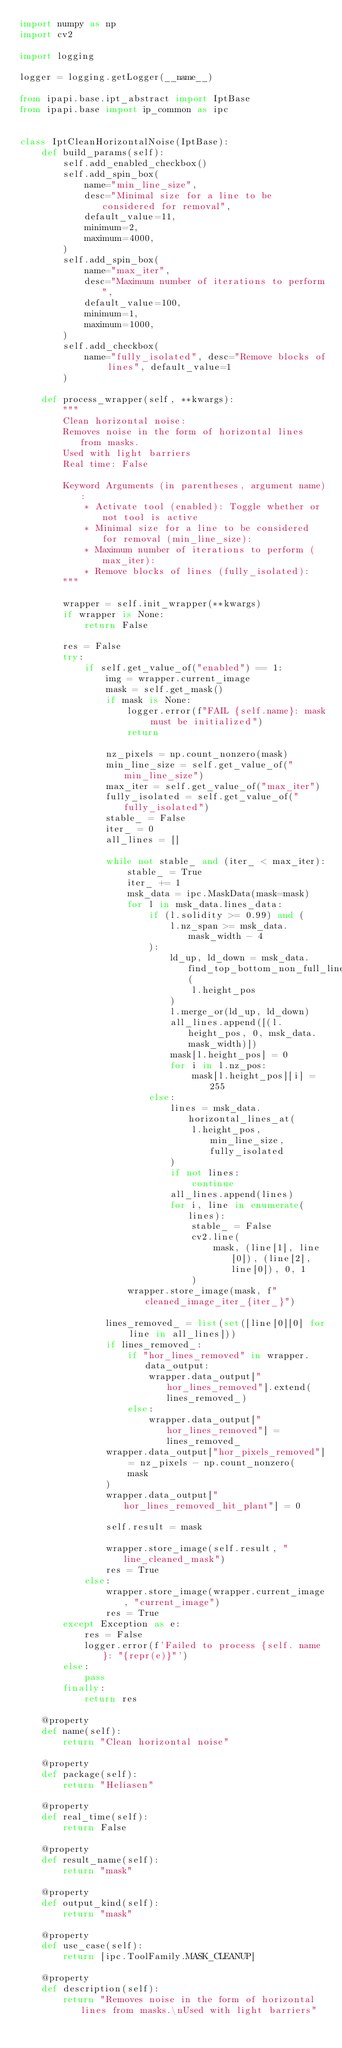Convert code to text. <code><loc_0><loc_0><loc_500><loc_500><_Python_>import numpy as np
import cv2

import logging

logger = logging.getLogger(__name__)

from ipapi.base.ipt_abstract import IptBase
from ipapi.base import ip_common as ipc


class IptCleanHorizontalNoise(IptBase):
    def build_params(self):
        self.add_enabled_checkbox()
        self.add_spin_box(
            name="min_line_size",
            desc="Minimal size for a line to be considered for removal",
            default_value=11,
            minimum=2,
            maximum=4000,
        )
        self.add_spin_box(
            name="max_iter",
            desc="Maximum number of iterations to perform",
            default_value=100,
            minimum=1,
            maximum=1000,
        )
        self.add_checkbox(
            name="fully_isolated", desc="Remove blocks of lines", default_value=1
        )

    def process_wrapper(self, **kwargs):
        """
        Clean horizontal noise:
        Removes noise in the form of horizontal lines from masks.
        Used with light barriers
        Real time: False

        Keyword Arguments (in parentheses, argument name):
            * Activate tool (enabled): Toggle whether or not tool is active
            * Minimal size for a line to be considered for removal (min_line_size):
            * Maximum number of iterations to perform (max_iter):
            * Remove blocks of lines (fully_isolated):
        """

        wrapper = self.init_wrapper(**kwargs)
        if wrapper is None:
            return False

        res = False
        try:
            if self.get_value_of("enabled") == 1:
                img = wrapper.current_image
                mask = self.get_mask()
                if mask is None:
                    logger.error(f"FAIL {self.name}: mask must be initialized")
                    return

                nz_pixels = np.count_nonzero(mask)
                min_line_size = self.get_value_of("min_line_size")
                max_iter = self.get_value_of("max_iter")
                fully_isolated = self.get_value_of("fully_isolated")
                stable_ = False
                iter_ = 0
                all_lines = []

                while not stable_ and (iter_ < max_iter):
                    stable_ = True
                    iter_ += 1
                    msk_data = ipc.MaskData(mask=mask)
                    for l in msk_data.lines_data:
                        if (l.solidity >= 0.99) and (
                            l.nz_span >= msk_data.mask_width - 4
                        ):
                            ld_up, ld_down = msk_data.find_top_bottom_non_full_lines(
                                l.height_pos
                            )
                            l.merge_or(ld_up, ld_down)
                            all_lines.append([(l.height_pos, 0, msk_data.mask_width)])
                            mask[l.height_pos] = 0
                            for i in l.nz_pos:
                                mask[l.height_pos][i] = 255
                        else:
                            lines = msk_data.horizontal_lines_at(
                                l.height_pos, min_line_size, fully_isolated
                            )
                            if not lines:
                                continue
                            all_lines.append(lines)
                            for i, line in enumerate(lines):
                                stable_ = False
                                cv2.line(
                                    mask, (line[1], line[0]), (line[2], line[0]), 0, 1
                                )
                    wrapper.store_image(mask, f"cleaned_image_iter_{iter_}")

                lines_removed_ = list(set([line[0][0] for line in all_lines]))
                if lines_removed_:
                    if "hor_lines_removed" in wrapper.data_output:
                        wrapper.data_output["hor_lines_removed"].extend(lines_removed_)
                    else:
                        wrapper.data_output["hor_lines_removed"] = lines_removed_
                wrapper.data_output["hor_pixels_removed"] = nz_pixels - np.count_nonzero(
                    mask
                )
                wrapper.data_output["hor_lines_removed_hit_plant"] = 0

                self.result = mask

                wrapper.store_image(self.result, "line_cleaned_mask")
                res = True
            else:
                wrapper.store_image(wrapper.current_image, "current_image")
                res = True
        except Exception as e:
            res = False
            logger.error(f'Failed to process {self. name}: "{repr(e)}"')
        else:
            pass
        finally:
            return res

    @property
    def name(self):
        return "Clean horizontal noise"

    @property
    def package(self):
        return "Heliasen"

    @property
    def real_time(self):
        return False

    @property
    def result_name(self):
        return "mask"

    @property
    def output_kind(self):
        return "mask"

    @property
    def use_case(self):
        return [ipc.ToolFamily.MASK_CLEANUP]

    @property
    def description(self):
        return "Removes noise in the form of horizontal lines from masks.\nUsed with light barriers"
</code> 